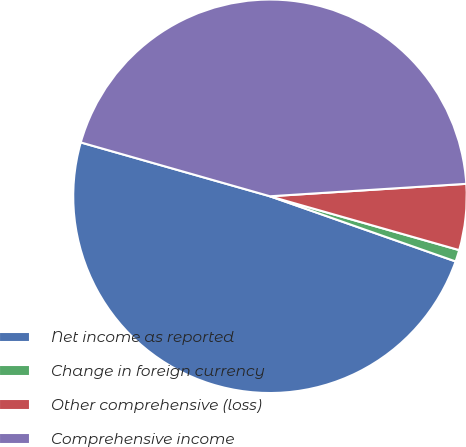Convert chart. <chart><loc_0><loc_0><loc_500><loc_500><pie_chart><fcel>Net income as reported<fcel>Change in foreign currency<fcel>Other comprehensive (loss)<fcel>Comprehensive income<nl><fcel>49.04%<fcel>0.96%<fcel>5.42%<fcel>44.58%<nl></chart> 